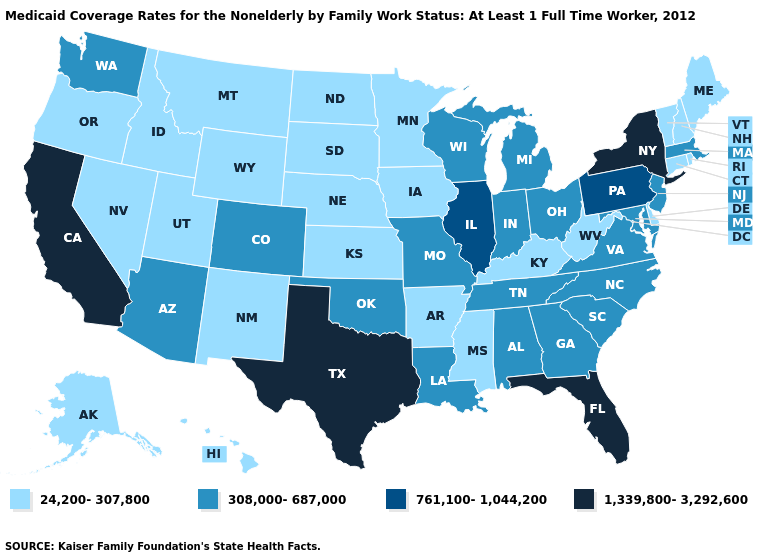What is the value of Hawaii?
Short answer required. 24,200-307,800. Is the legend a continuous bar?
Keep it brief. No. Among the states that border Montana , which have the highest value?
Be succinct. Idaho, North Dakota, South Dakota, Wyoming. What is the highest value in the USA?
Write a very short answer. 1,339,800-3,292,600. What is the value of Illinois?
Be succinct. 761,100-1,044,200. What is the value of Arkansas?
Answer briefly. 24,200-307,800. Among the states that border Virginia , does Tennessee have the lowest value?
Give a very brief answer. No. Does the map have missing data?
Give a very brief answer. No. What is the highest value in the USA?
Keep it brief. 1,339,800-3,292,600. Which states have the lowest value in the MidWest?
Be succinct. Iowa, Kansas, Minnesota, Nebraska, North Dakota, South Dakota. Does the first symbol in the legend represent the smallest category?
Short answer required. Yes. What is the value of Wyoming?
Be succinct. 24,200-307,800. What is the value of Connecticut?
Short answer required. 24,200-307,800. Which states have the lowest value in the Northeast?
Answer briefly. Connecticut, Maine, New Hampshire, Rhode Island, Vermont. Is the legend a continuous bar?
Give a very brief answer. No. 